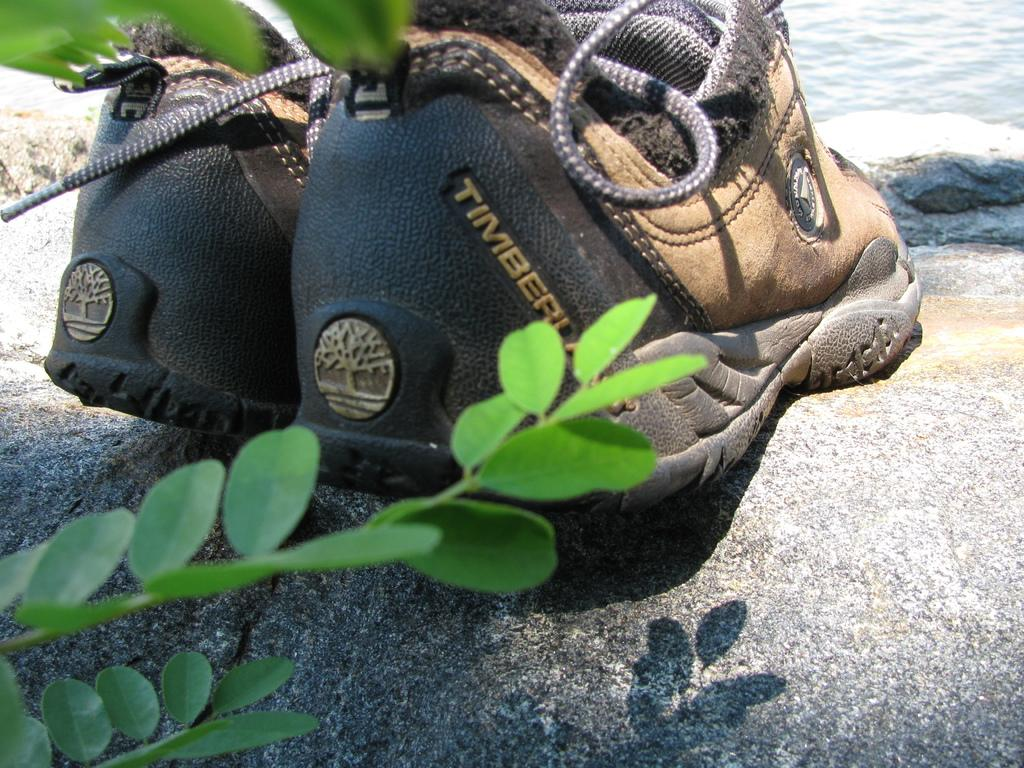What type of footwear is present in the image? There are shoes in the image. What part of a tree can be seen in the image? The stem of a tree is visible in the image. What type of natural objects are present in the image? There are rocks in the image. What body of water can be seen in the image? There is water visible in the image. What type of love can be seen between the beetle and the fog in the image? There is no beetle or fog present in the image, so there is no love to be seen between them. 